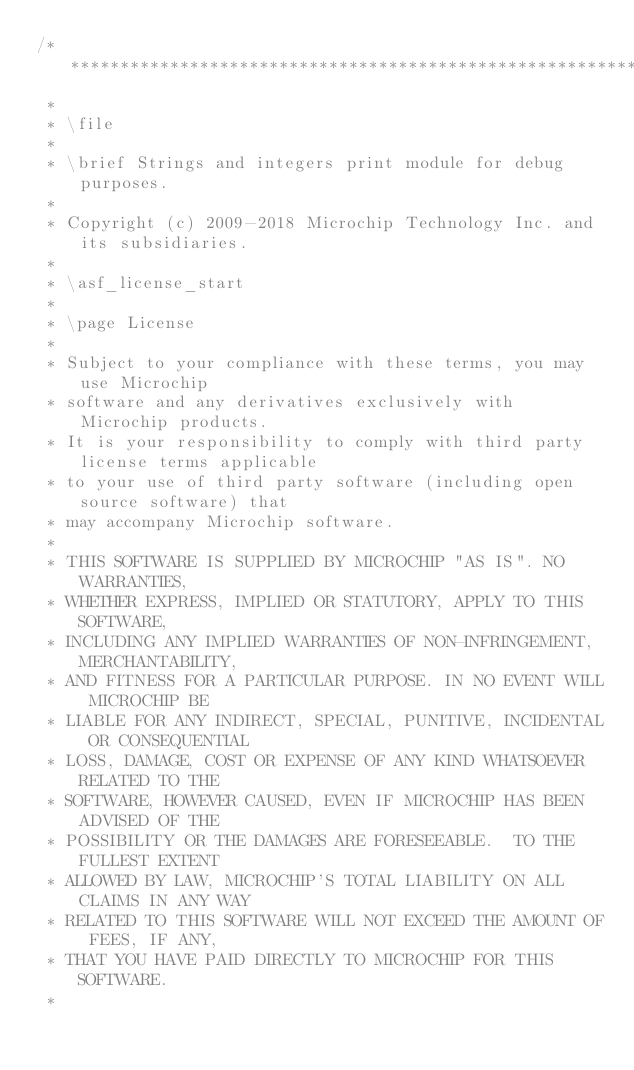Convert code to text. <code><loc_0><loc_0><loc_500><loc_500><_C_>/*****************************************************************************
 *
 * \file
 *
 * \brief Strings and integers print module for debug purposes.
 *
 * Copyright (c) 2009-2018 Microchip Technology Inc. and its subsidiaries.
 *
 * \asf_license_start
 *
 * \page License
 *
 * Subject to your compliance with these terms, you may use Microchip
 * software and any derivatives exclusively with Microchip products.
 * It is your responsibility to comply with third party license terms applicable
 * to your use of third party software (including open source software) that
 * may accompany Microchip software.
 *
 * THIS SOFTWARE IS SUPPLIED BY MICROCHIP "AS IS". NO WARRANTIES,
 * WHETHER EXPRESS, IMPLIED OR STATUTORY, APPLY TO THIS SOFTWARE,
 * INCLUDING ANY IMPLIED WARRANTIES OF NON-INFRINGEMENT, MERCHANTABILITY,
 * AND FITNESS FOR A PARTICULAR PURPOSE. IN NO EVENT WILL MICROCHIP BE
 * LIABLE FOR ANY INDIRECT, SPECIAL, PUNITIVE, INCIDENTAL OR CONSEQUENTIAL
 * LOSS, DAMAGE, COST OR EXPENSE OF ANY KIND WHATSOEVER RELATED TO THE
 * SOFTWARE, HOWEVER CAUSED, EVEN IF MICROCHIP HAS BEEN ADVISED OF THE
 * POSSIBILITY OR THE DAMAGES ARE FORESEEABLE.  TO THE FULLEST EXTENT
 * ALLOWED BY LAW, MICROCHIP'S TOTAL LIABILITY ON ALL CLAIMS IN ANY WAY
 * RELATED TO THIS SOFTWARE WILL NOT EXCEED THE AMOUNT OF FEES, IF ANY,
 * THAT YOU HAVE PAID DIRECTLY TO MICROCHIP FOR THIS SOFTWARE.
 *</code> 